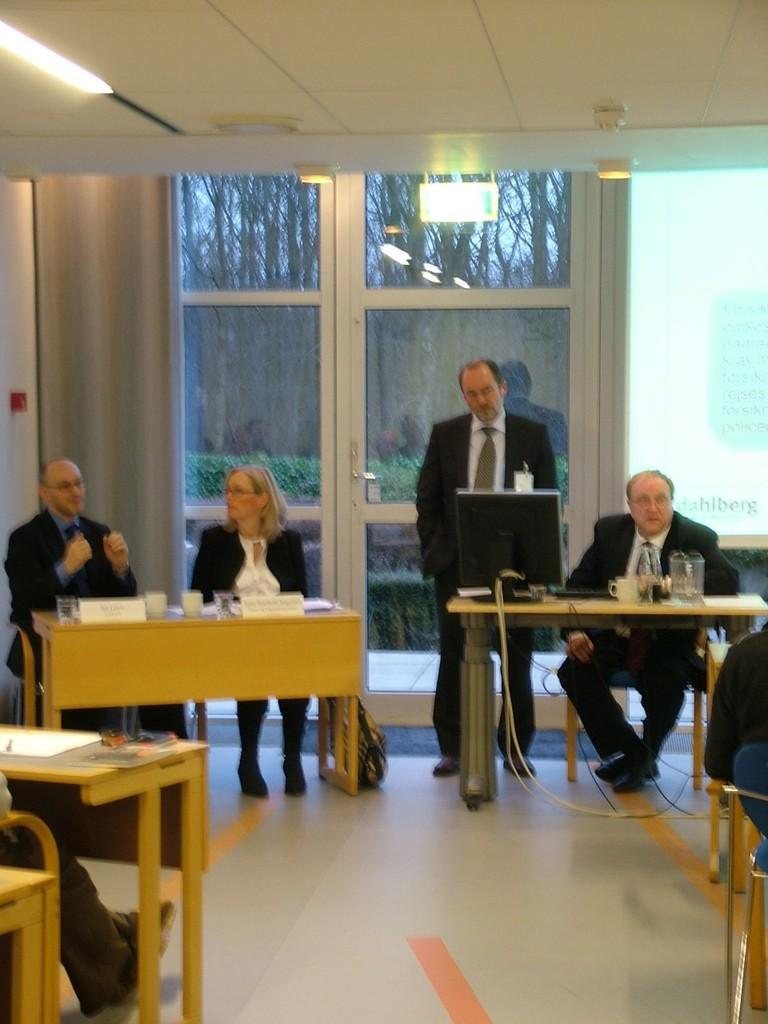Describe this image in one or two sentences. In this picture we can see some people sitting on chairs and here person is standing and in front of them there is table and on table we can see monitors, jar, glasses, name boards, papers and in background we can see screen, glass, wall, trees. 